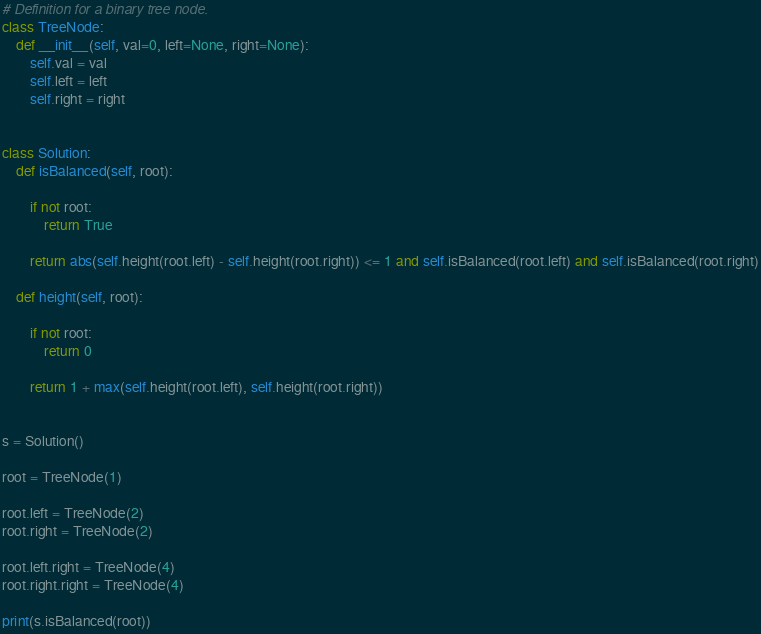<code> <loc_0><loc_0><loc_500><loc_500><_Python_># Definition for a binary tree node.
class TreeNode:
    def __init__(self, val=0, left=None, right=None):
        self.val = val
        self.left = left
        self.right = right


class Solution:
    def isBalanced(self, root):

        if not root:
            return True

        return abs(self.height(root.left) - self.height(root.right)) <= 1 and self.isBalanced(root.left) and self.isBalanced(root.right)

    def height(self, root):

        if not root:
            return 0

        return 1 + max(self.height(root.left), self.height(root.right))


s = Solution()

root = TreeNode(1)

root.left = TreeNode(2)
root.right = TreeNode(2)

root.left.right = TreeNode(4)
root.right.right = TreeNode(4)

print(s.isBalanced(root))
</code> 